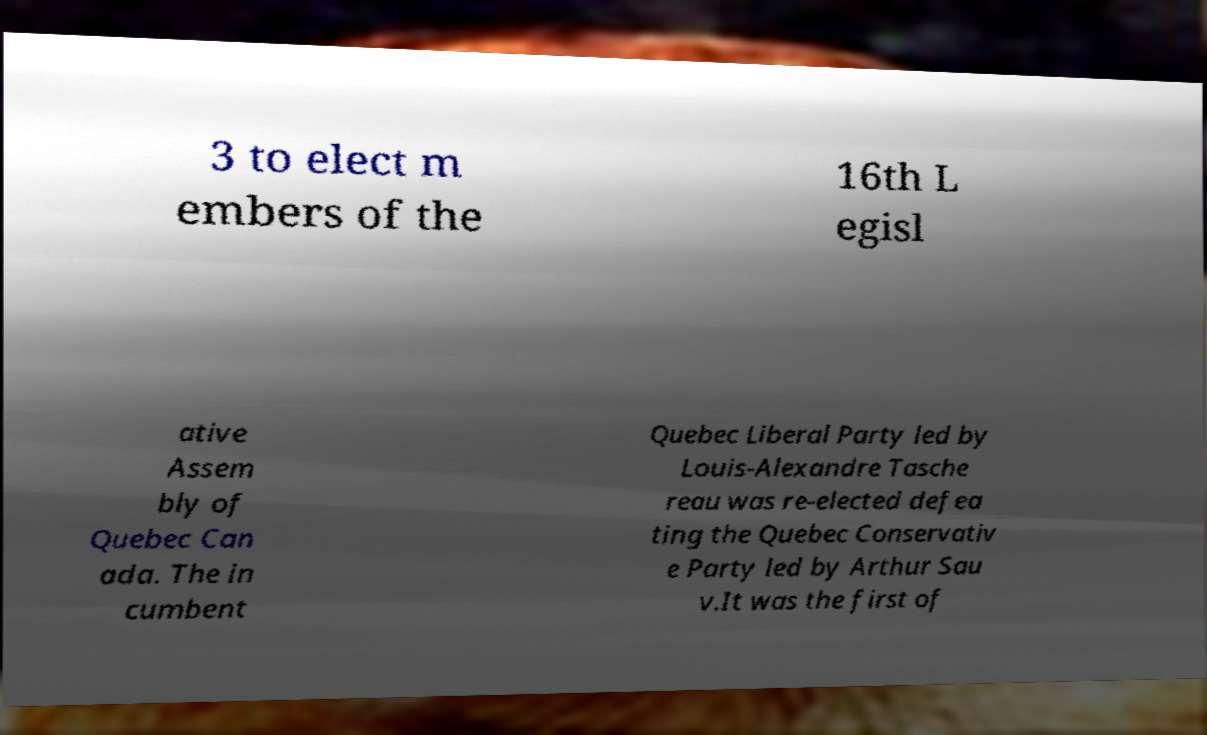I need the written content from this picture converted into text. Can you do that? 3 to elect m embers of the 16th L egisl ative Assem bly of Quebec Can ada. The in cumbent Quebec Liberal Party led by Louis-Alexandre Tasche reau was re-elected defea ting the Quebec Conservativ e Party led by Arthur Sau v.It was the first of 